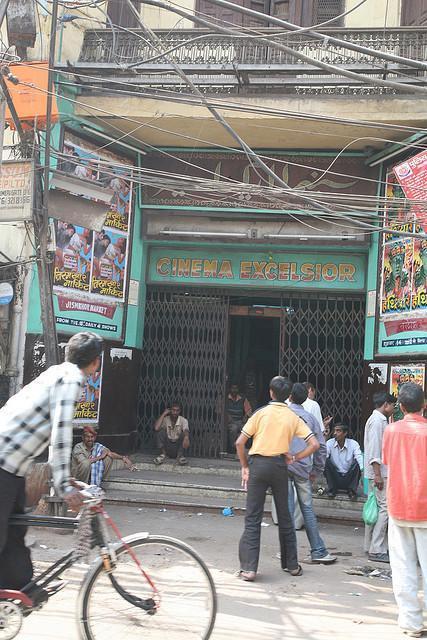How many people are in the picture?
Give a very brief answer. 7. 